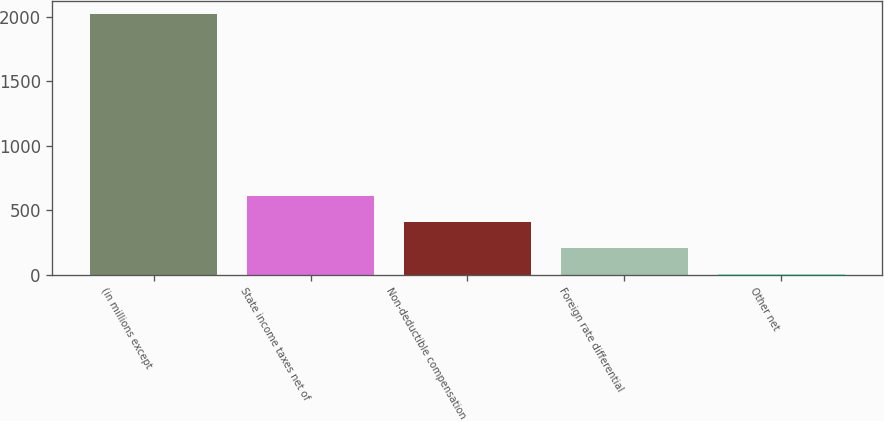Convert chart. <chart><loc_0><loc_0><loc_500><loc_500><bar_chart><fcel>(in millions except<fcel>State income taxes net of<fcel>Non-deductible compensation<fcel>Foreign rate differential<fcel>Other net<nl><fcel>2016<fcel>605.22<fcel>403.68<fcel>202.14<fcel>0.6<nl></chart> 